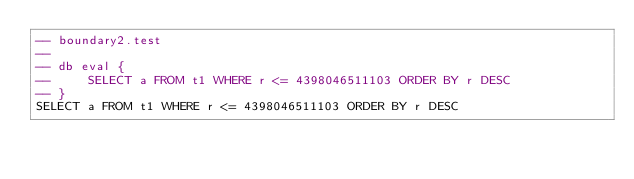Convert code to text. <code><loc_0><loc_0><loc_500><loc_500><_SQL_>-- boundary2.test
-- 
-- db eval {
--     SELECT a FROM t1 WHERE r <= 4398046511103 ORDER BY r DESC
-- }
SELECT a FROM t1 WHERE r <= 4398046511103 ORDER BY r DESC</code> 